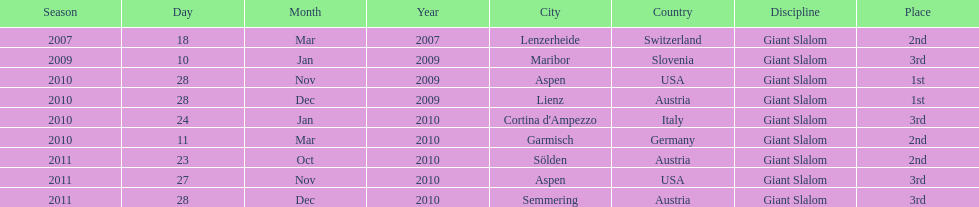What is the total number of her 2nd place finishes on the list? 3. 